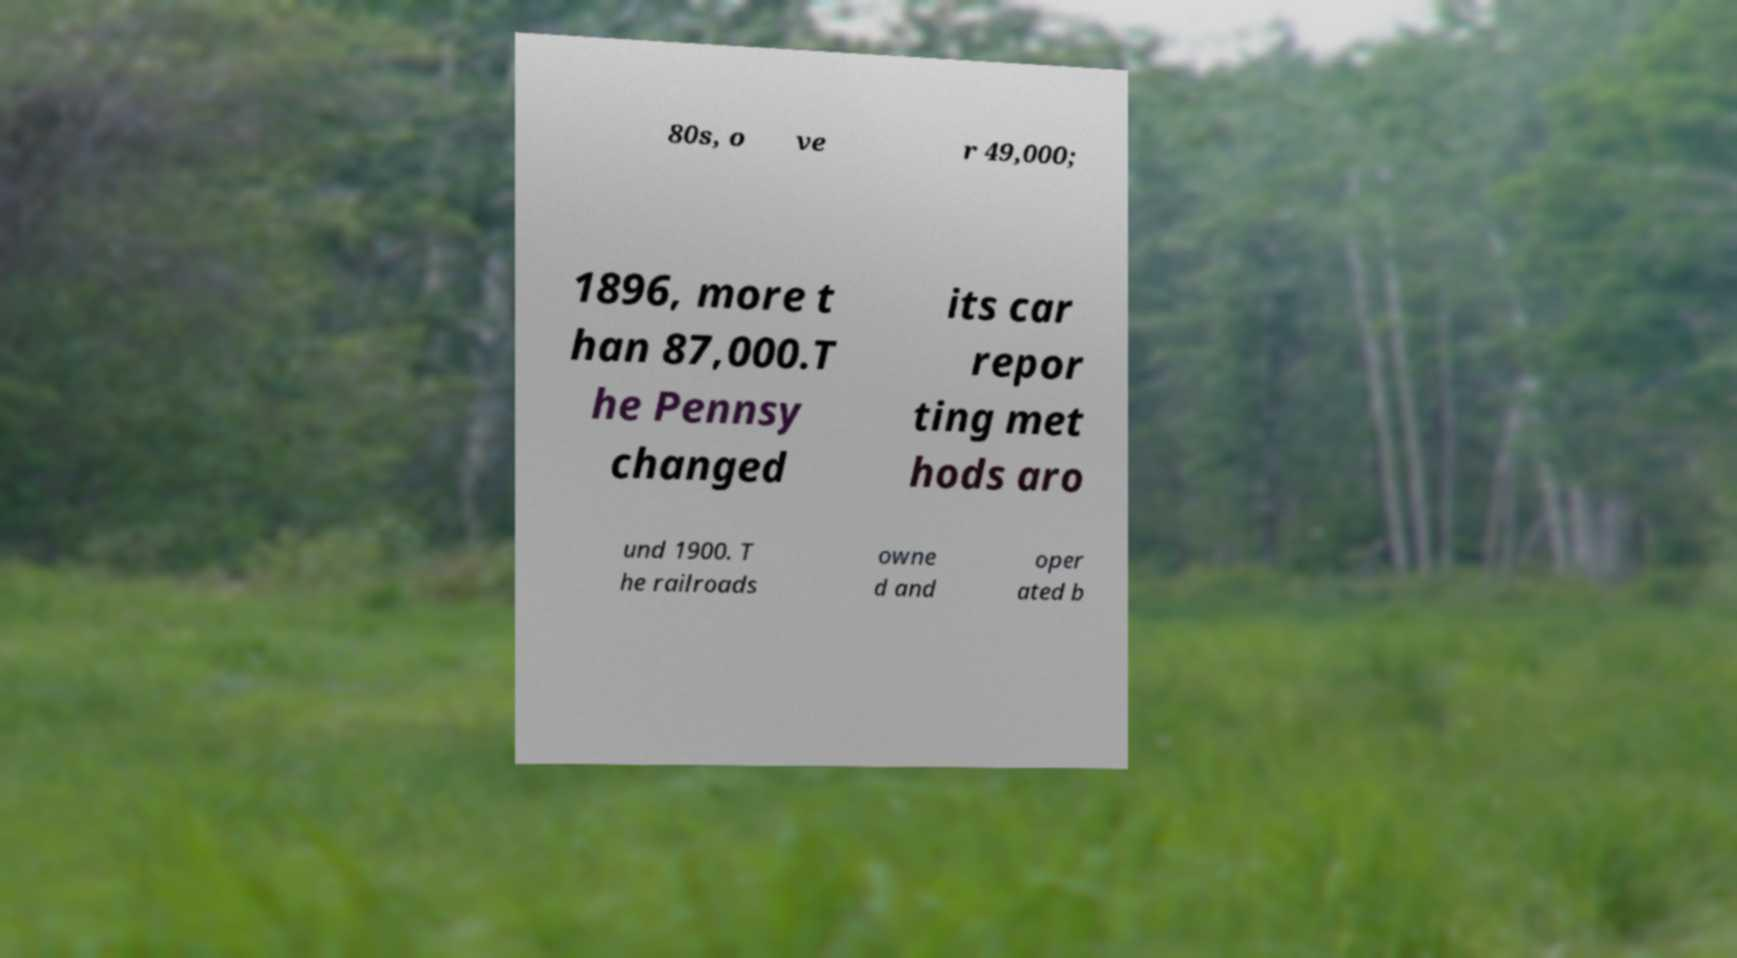For documentation purposes, I need the text within this image transcribed. Could you provide that? 80s, o ve r 49,000; 1896, more t han 87,000.T he Pennsy changed its car repor ting met hods aro und 1900. T he railroads owne d and oper ated b 